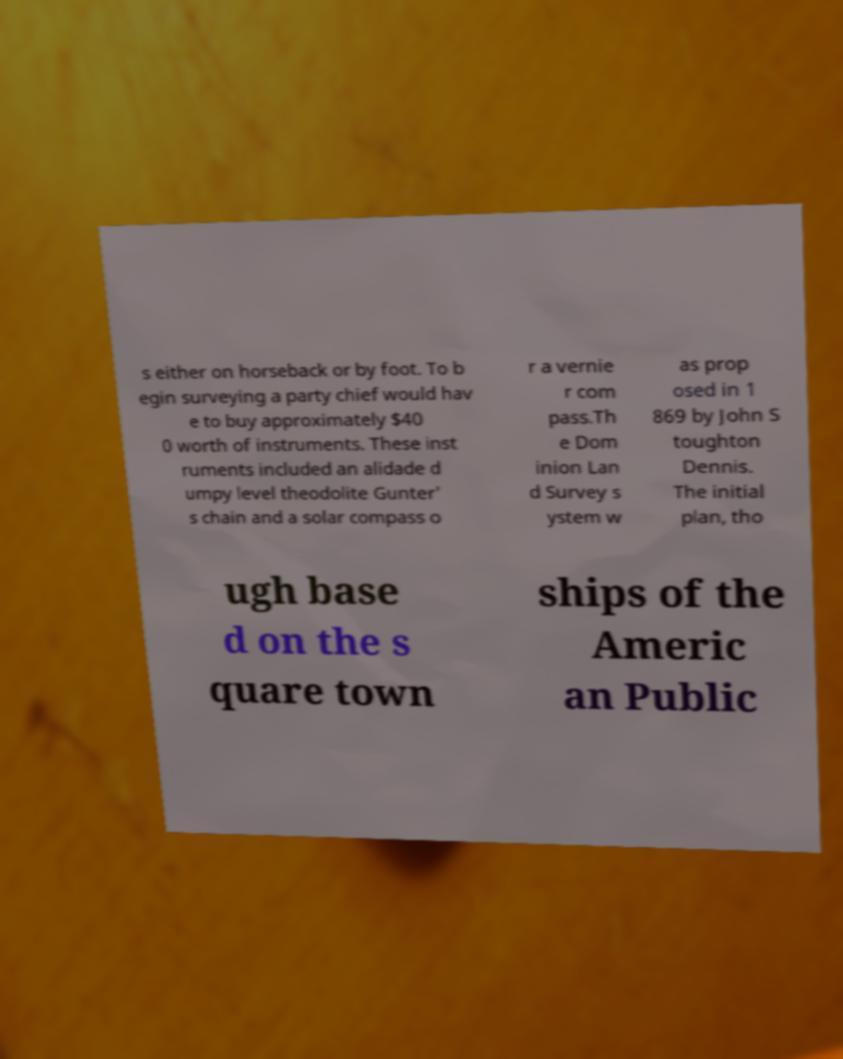Can you read and provide the text displayed in the image?This photo seems to have some interesting text. Can you extract and type it out for me? s either on horseback or by foot. To b egin surveying a party chief would hav e to buy approximately $40 0 worth of instruments. These inst ruments included an alidade d umpy level theodolite Gunter' s chain and a solar compass o r a vernie r com pass.Th e Dom inion Lan d Survey s ystem w as prop osed in 1 869 by John S toughton Dennis. The initial plan, tho ugh base d on the s quare town ships of the Americ an Public 